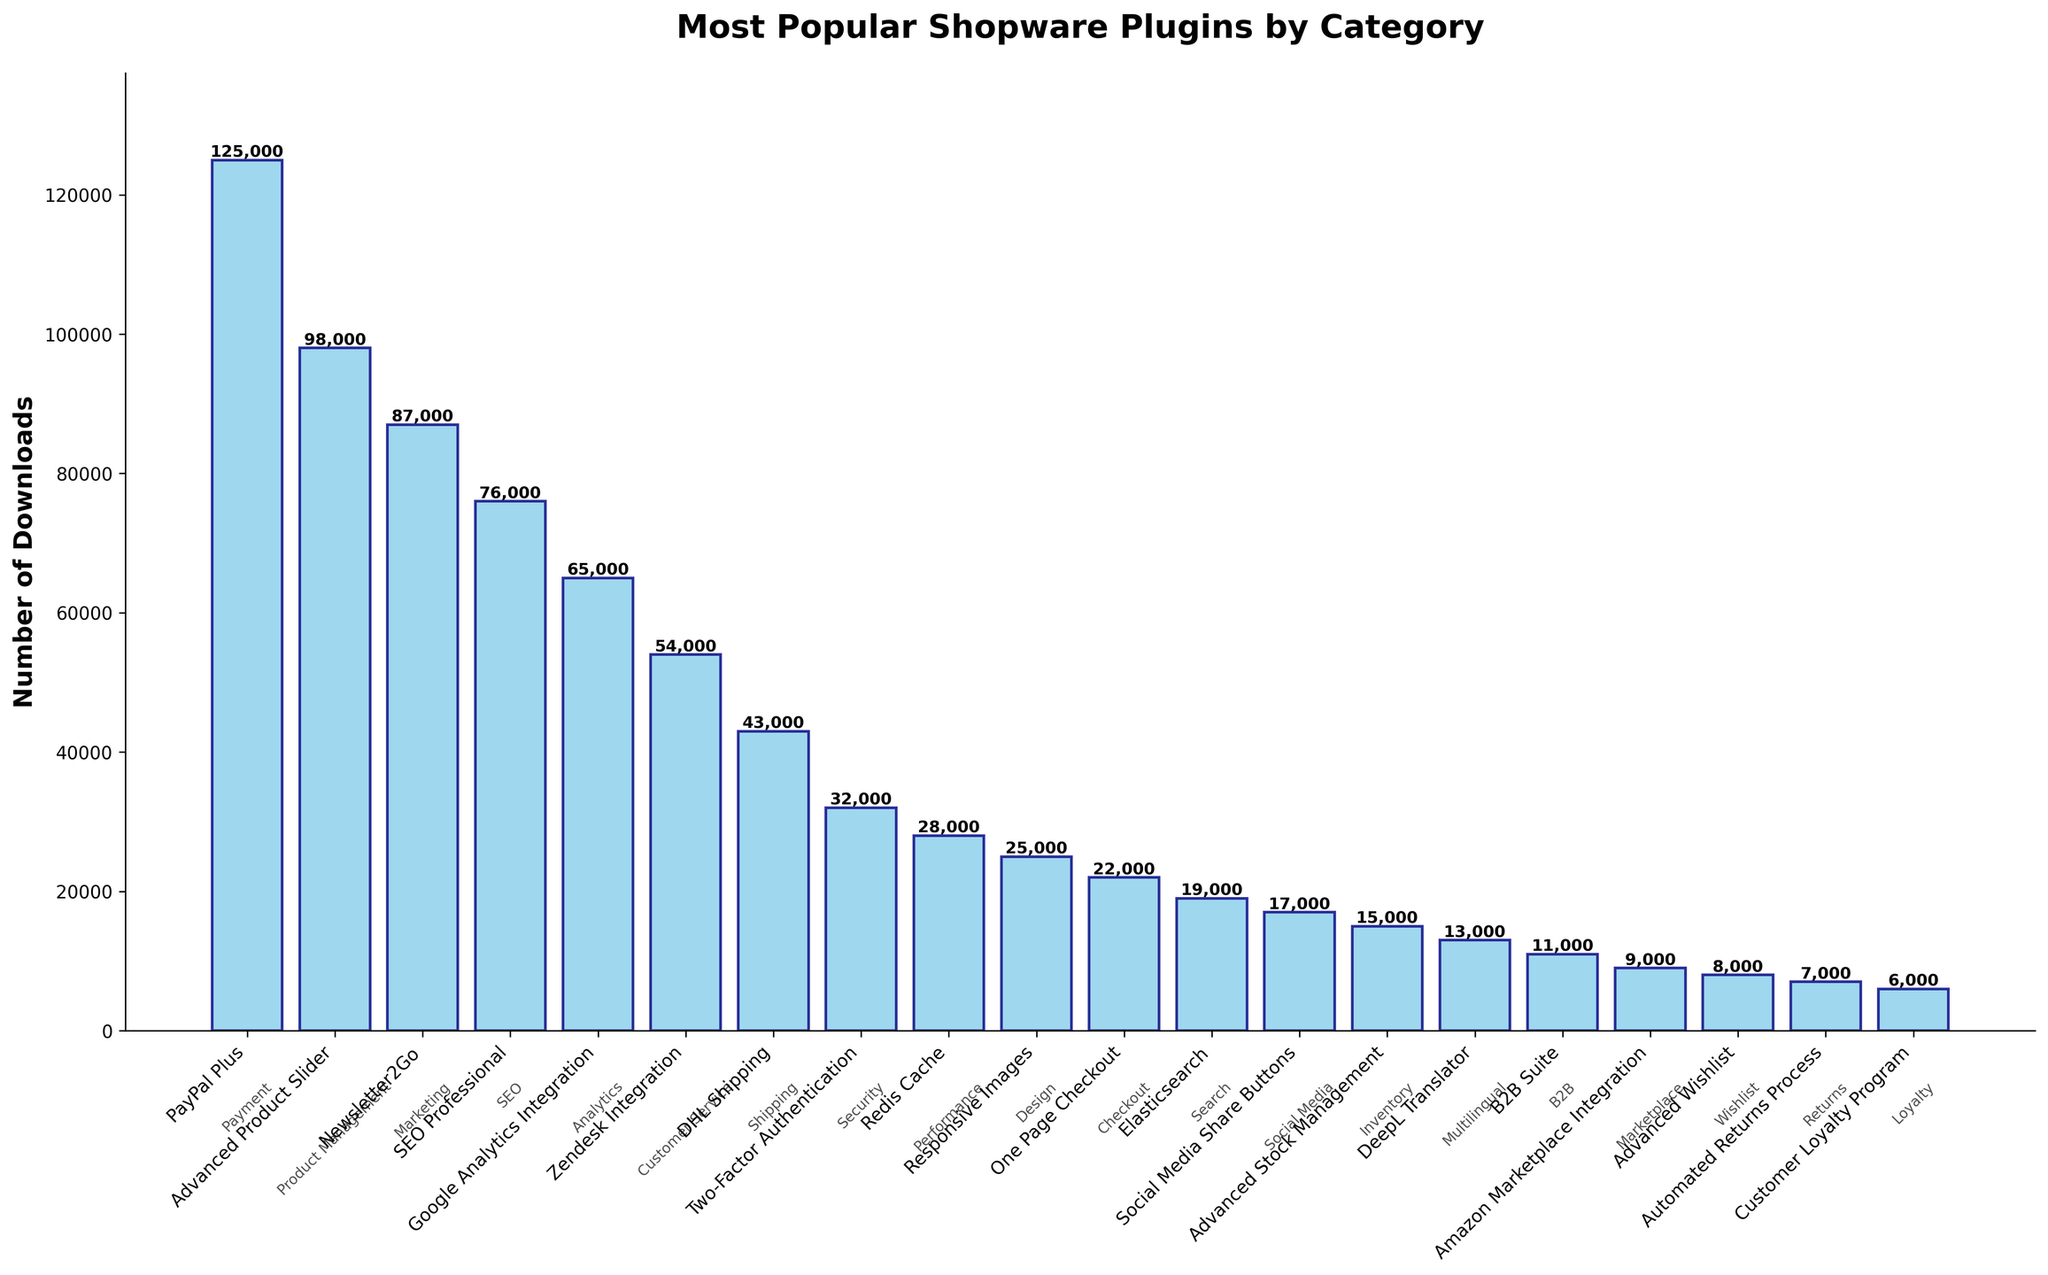Which plugin has the highest number of downloads? By examining the heights of the bars, the tallest one corresponds to PayPal Plus, indicating it has the highest number of downloads.
Answer: PayPal Plus Which category has the plugin with the least number of downloads? The shortest bar on the chart corresponds to the Automated Returns Process plugin, which belongs to the Returns category.
Answer: Returns What is the total number of downloads for the plugins in the top 3 categories combined? The top 3 categories by plugin downloads are Payment (PayPal Plus, 125,000), Product Management (Advanced Product Slider, 98,000), and Marketing (Newsletter2Go, 87,000). Adding these numbers gives 125,000 + 98,000 + 87,000 = 310,000.
Answer: 310,000 How many categories have plugins with more than 50,000 downloads? By visually scanning the chart, the categories with more than 50,000 downloads are Payment, Product Management, Marketing, SEO, and Analytics. This totals 5 categories.
Answer: 5 How do the number of downloads for SEO Professional and Google Analytics Integration compare? The height of the bar for SEO Professional (76,000) is taller than that for Google Analytics Integration (65,000), indicating SEO Professional has more downloads.
Answer: SEO Professional has more downloads Which plugin related to customer service has had the most success in terms of downloads? The plugin listed under Customer Service is Zendesk Integration, and its number of downloads is 54,000.
Answer: Zendesk Integration What is the difference in the number of downloads between the most and least popular plugins? The most popular is PayPal Plus (125,000 downloads) and the least popular is Customer Loyalty Program (6,000 downloads). The difference is 125,000 – 6,000 = 119,000.
Answer: 119,000 How many plugins have download counts between 10,000 and 20,000? By examining the bars, the plugins with download counts between 10,000 and 20,000 are Elasticsearch, Social Media Share Buttons, and DeepL Translator, totaling 3 plugins.
Answer: 3 Which category corresponds to the plugin with the third highest number of downloads, and how many downloads does it have? The third highest bar belongs to the Newsletter2Go plugin, which is in the Marketing category and has 87,000 downloads.
Answer: Marketing, 87,000 What percentage of the total downloads does the PayPal Plus plugin represent? Sum the downloads of all plugins to get the total (947,000); then calculate the percentage: (125,000 / 947,000) * 100 ≈ 13.2%.
Answer: 13.2% 